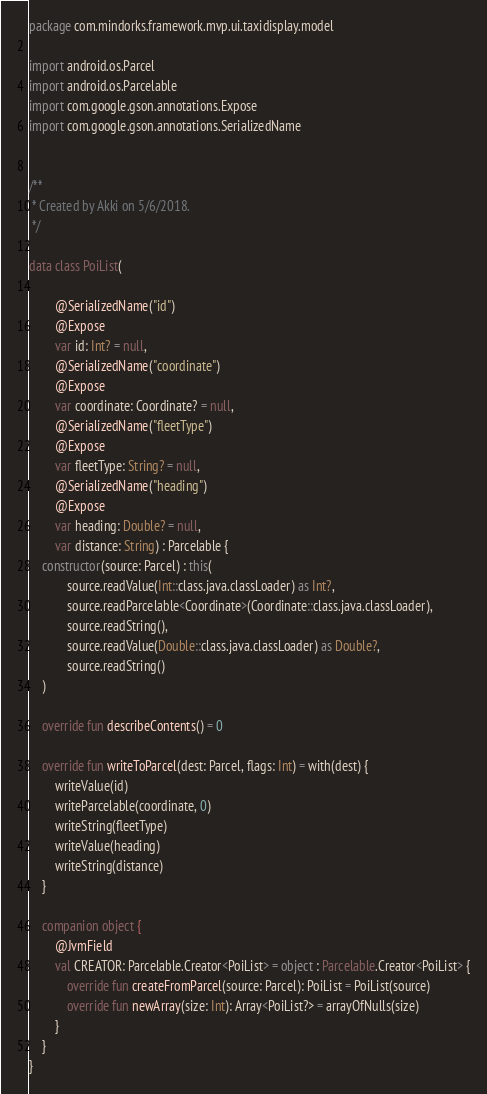Convert code to text. <code><loc_0><loc_0><loc_500><loc_500><_Kotlin_>package com.mindorks.framework.mvp.ui.taxidisplay.model

import android.os.Parcel
import android.os.Parcelable
import com.google.gson.annotations.Expose
import com.google.gson.annotations.SerializedName


/**
 * Created by Akki on 5/6/2018.
 */

data class PoiList(

        @SerializedName("id")
        @Expose
        var id: Int? = null,
        @SerializedName("coordinate")
        @Expose
        var coordinate: Coordinate? = null,
        @SerializedName("fleetType")
        @Expose
        var fleetType: String? = null,
        @SerializedName("heading")
        @Expose
        var heading: Double? = null,
        var distance: String) : Parcelable {
    constructor(source: Parcel) : this(
            source.readValue(Int::class.java.classLoader) as Int?,
            source.readParcelable<Coordinate>(Coordinate::class.java.classLoader),
            source.readString(),
            source.readValue(Double::class.java.classLoader) as Double?,
            source.readString()
    )

    override fun describeContents() = 0

    override fun writeToParcel(dest: Parcel, flags: Int) = with(dest) {
        writeValue(id)
        writeParcelable(coordinate, 0)
        writeString(fleetType)
        writeValue(heading)
        writeString(distance)
    }

    companion object {
        @JvmField
        val CREATOR: Parcelable.Creator<PoiList> = object : Parcelable.Creator<PoiList> {
            override fun createFromParcel(source: Parcel): PoiList = PoiList(source)
            override fun newArray(size: Int): Array<PoiList?> = arrayOfNulls(size)
        }
    }
}


</code> 